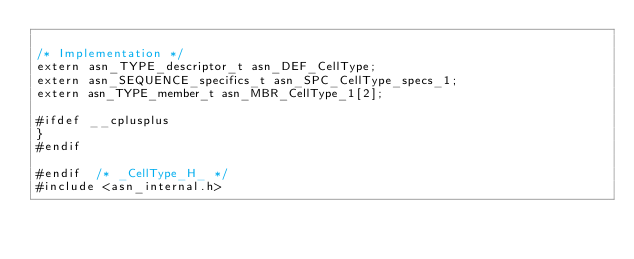<code> <loc_0><loc_0><loc_500><loc_500><_C_>
/* Implementation */
extern asn_TYPE_descriptor_t asn_DEF_CellType;
extern asn_SEQUENCE_specifics_t asn_SPC_CellType_specs_1;
extern asn_TYPE_member_t asn_MBR_CellType_1[2];

#ifdef __cplusplus
}
#endif

#endif	/* _CellType_H_ */
#include <asn_internal.h>
</code> 